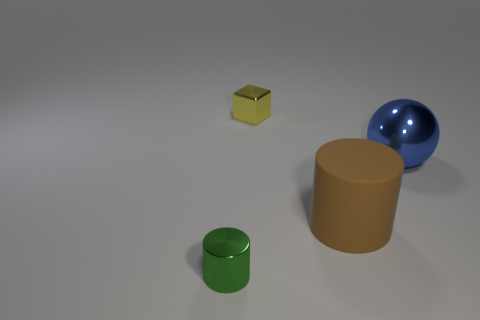Is the number of green objects on the right side of the yellow thing greater than the number of tiny metallic objects in front of the large ball?
Give a very brief answer. No. What shape is the small green thing that is the same material as the sphere?
Provide a short and direct response. Cylinder. How many other objects are there of the same shape as the large blue object?
Offer a terse response. 0. What shape is the tiny thing to the left of the tiny yellow shiny cube?
Keep it short and to the point. Cylinder. What is the color of the metallic cylinder?
Your answer should be compact. Green. How many other objects are the same size as the yellow shiny thing?
Your response must be concise. 1. What is the material of the tiny object left of the small object that is to the right of the metal cylinder?
Make the answer very short. Metal. There is a blue ball; does it have the same size as the shiny thing that is in front of the big blue object?
Your response must be concise. No. Is there a tiny metallic object of the same color as the big shiny object?
Your answer should be compact. No. What number of small things are either brown rubber cylinders or blocks?
Give a very brief answer. 1. 